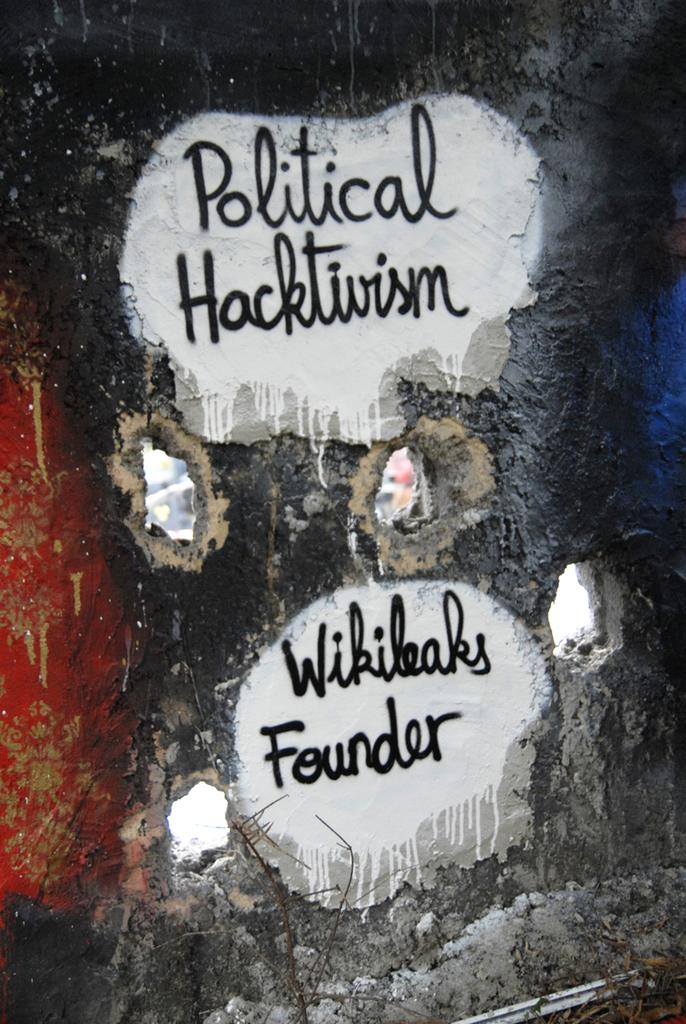What is written or displayed on the wall in the image? There is text on the wall in the image. Can you describe any other features or objects in the image? Yes, there are holes visible in the image. What type of cake is being served with cream in the image? There is no cake or cream present in the image; it only features text on the wall and holes. 